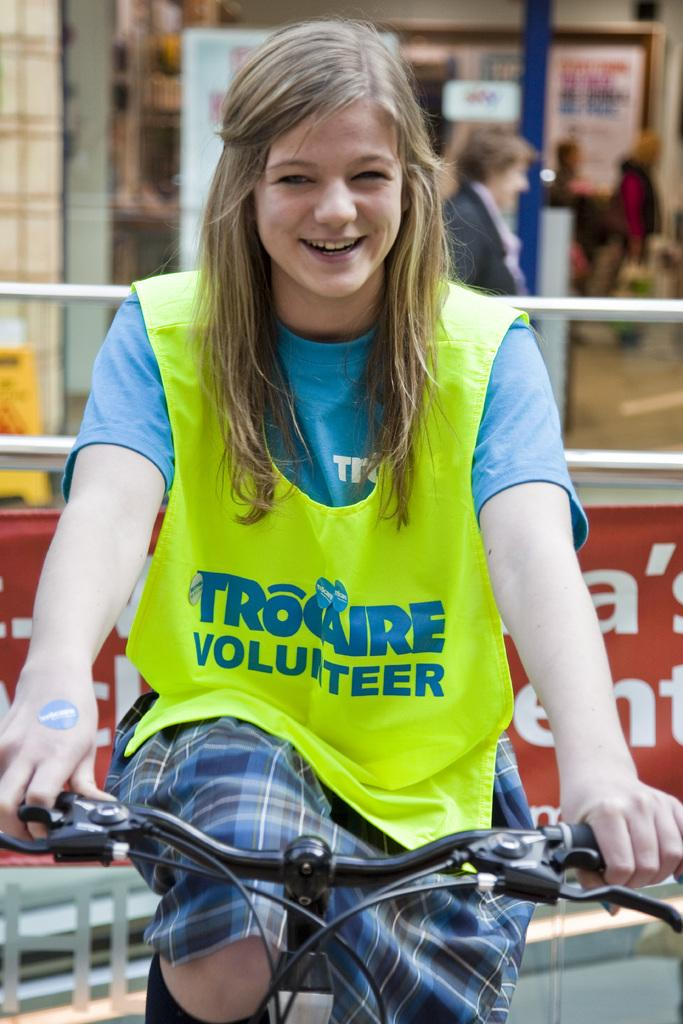Who is the main subject in the image? There is a woman in the image. What is the woman doing in the image? The woman is sitting on a bicycle. What is the woman's facial expression in the image? The woman is smiling. Where is the woman traveling in the image? The woman is traveling on a road. Can you describe the presence of another person in the image? There is another woman standing in the background. What type of lettuce can be seen growing on the side of the road in the image? There is no lettuce visible in the image; it is focused on the woman on the bicycle and the woman standing in the background. 